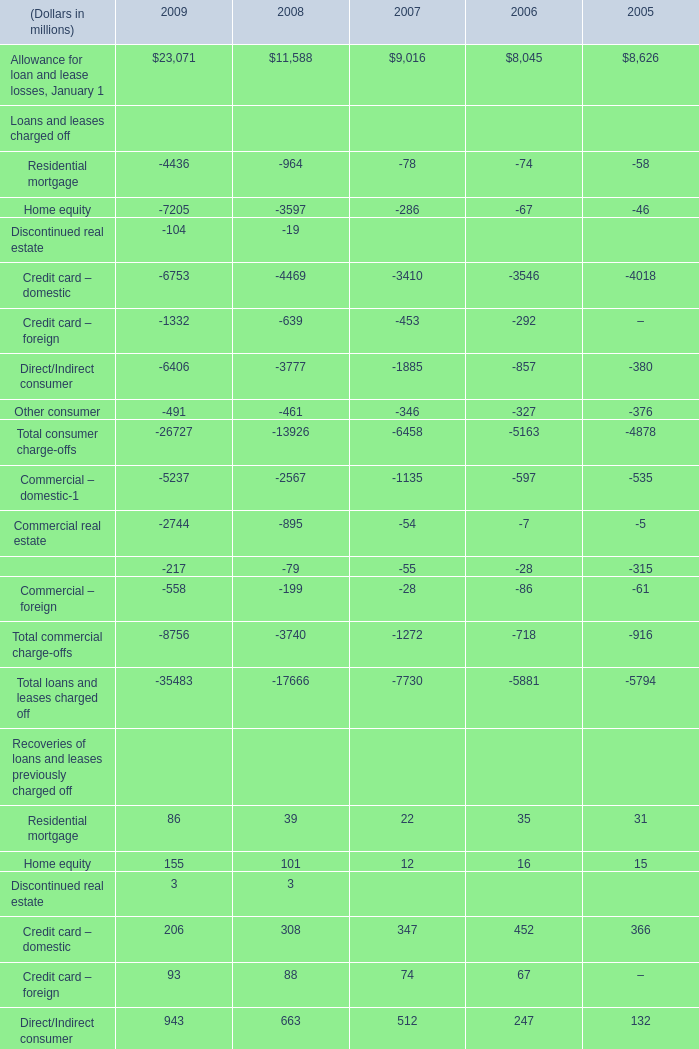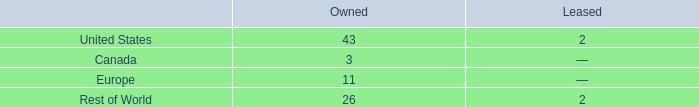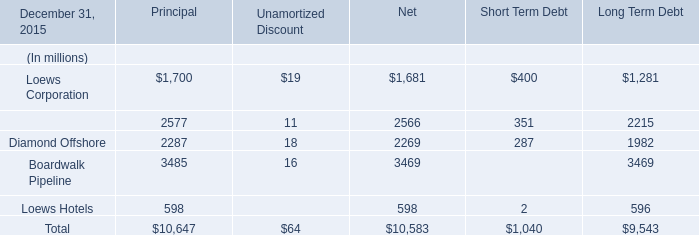Which year is Residential mortgage the most in terms of Recoveries of loans and leases previously charged off? 
Answer: 2009. 